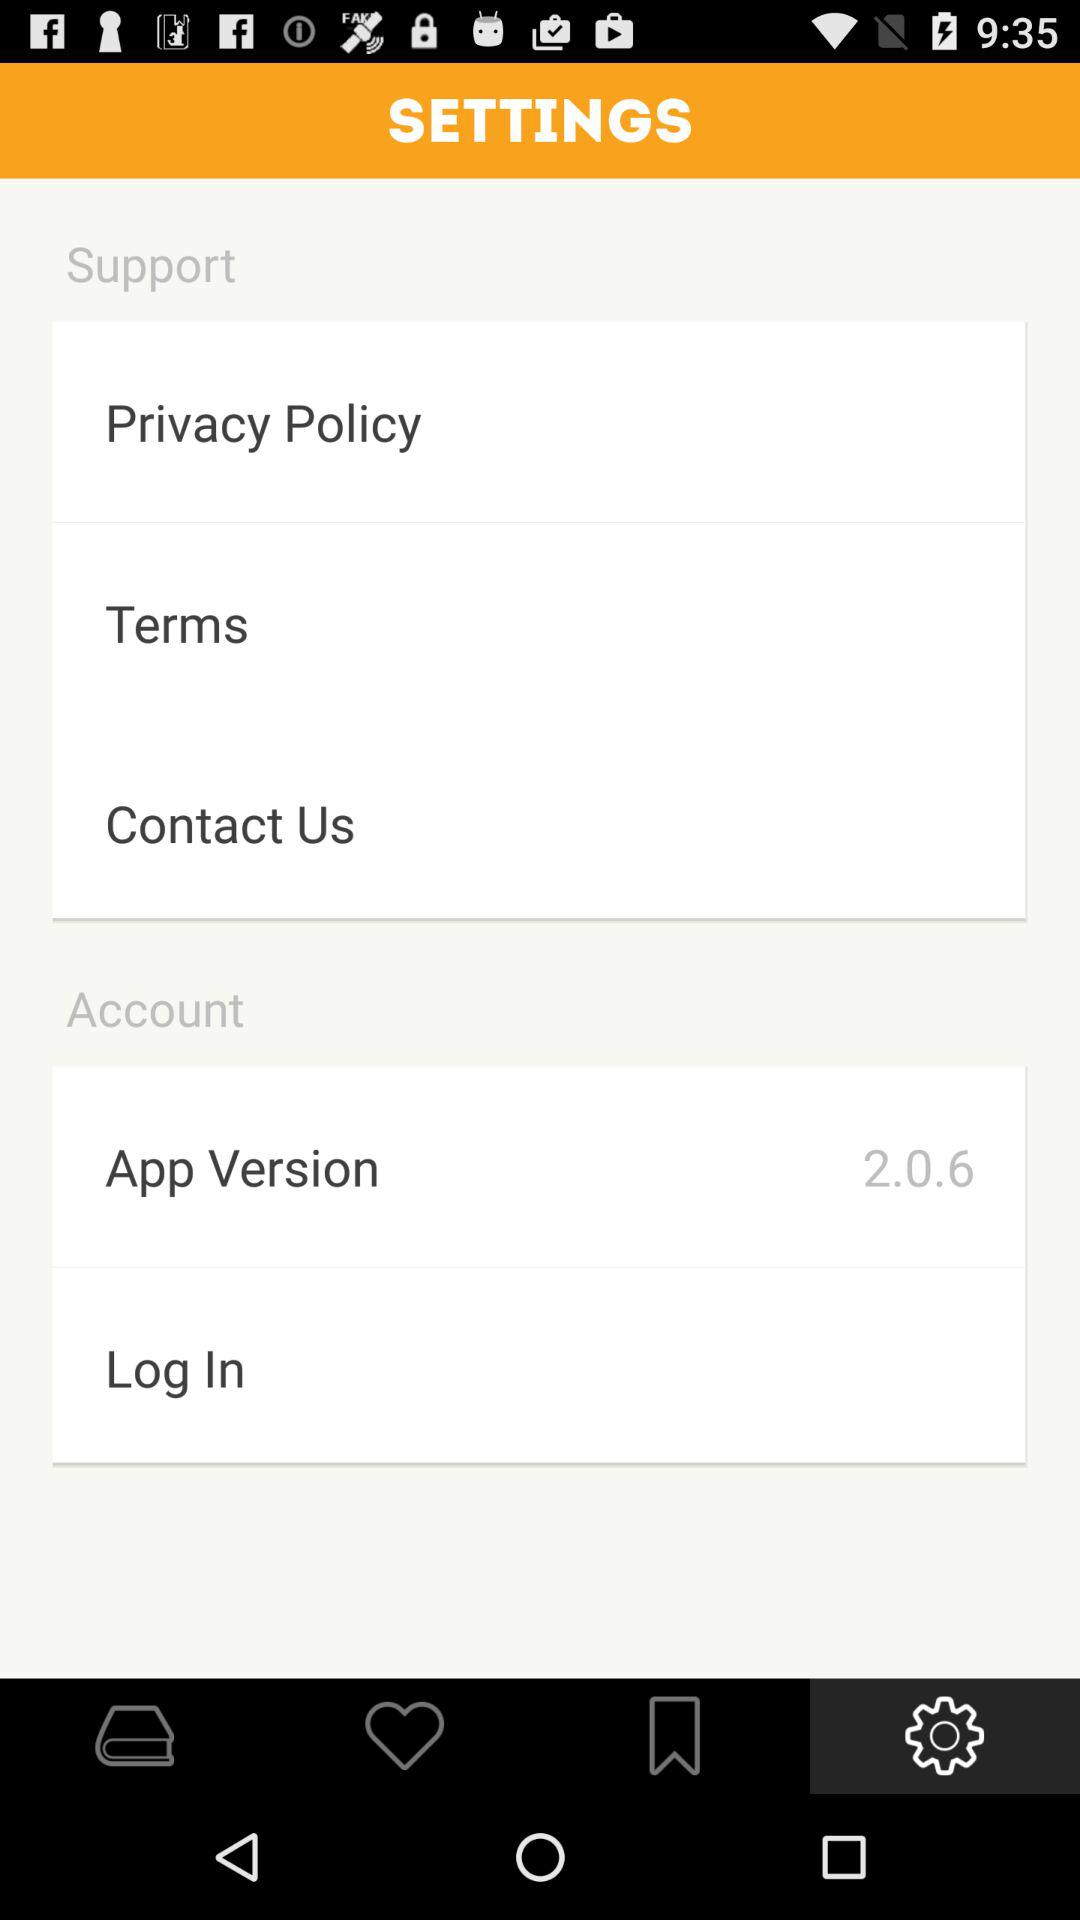What is the app version? The app version is 2.0.6. 